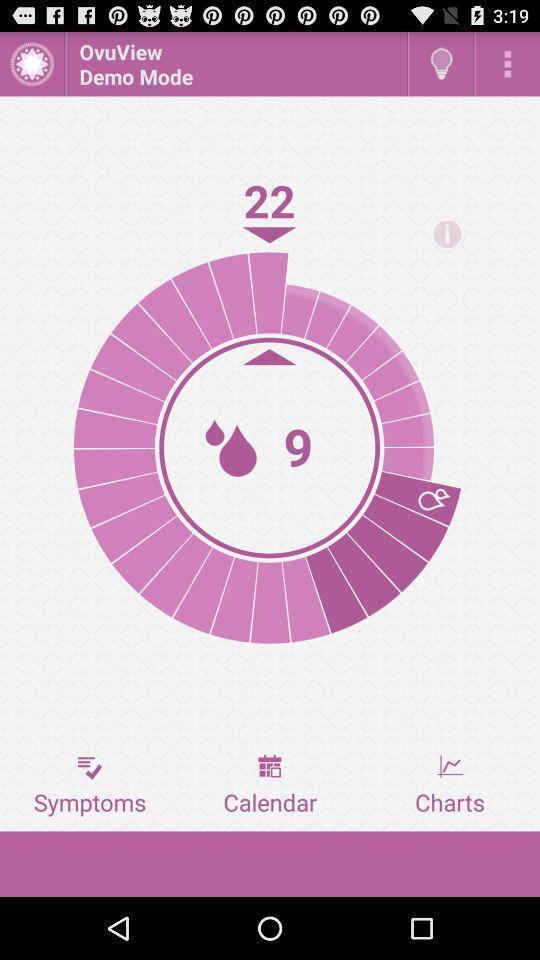Describe the visual elements of this screenshot. Screen shows a page of a pregnancy app. 